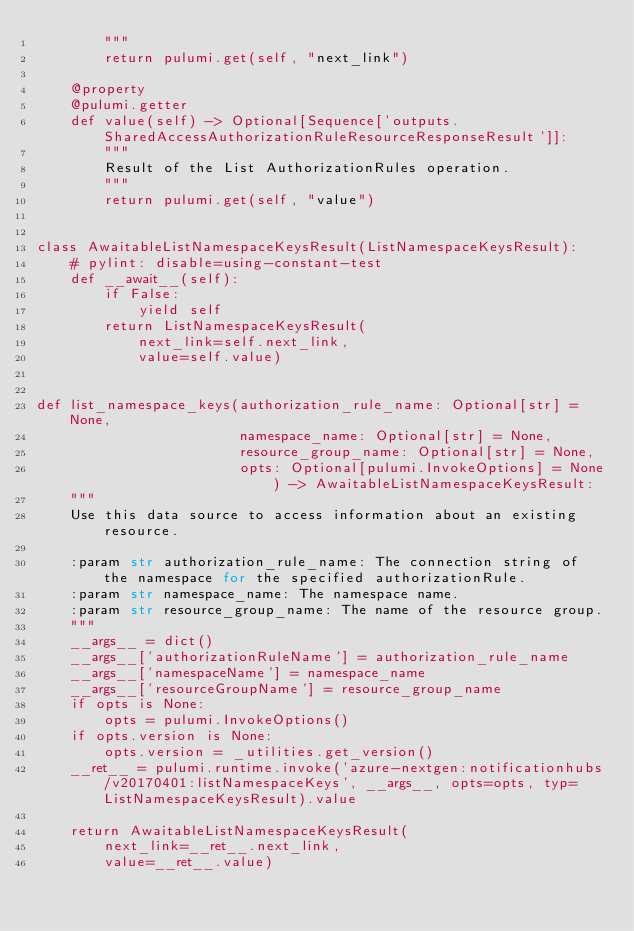<code> <loc_0><loc_0><loc_500><loc_500><_Python_>        """
        return pulumi.get(self, "next_link")

    @property
    @pulumi.getter
    def value(self) -> Optional[Sequence['outputs.SharedAccessAuthorizationRuleResourceResponseResult']]:
        """
        Result of the List AuthorizationRules operation.
        """
        return pulumi.get(self, "value")


class AwaitableListNamespaceKeysResult(ListNamespaceKeysResult):
    # pylint: disable=using-constant-test
    def __await__(self):
        if False:
            yield self
        return ListNamespaceKeysResult(
            next_link=self.next_link,
            value=self.value)


def list_namespace_keys(authorization_rule_name: Optional[str] = None,
                        namespace_name: Optional[str] = None,
                        resource_group_name: Optional[str] = None,
                        opts: Optional[pulumi.InvokeOptions] = None) -> AwaitableListNamespaceKeysResult:
    """
    Use this data source to access information about an existing resource.

    :param str authorization_rule_name: The connection string of the namespace for the specified authorizationRule.
    :param str namespace_name: The namespace name.
    :param str resource_group_name: The name of the resource group.
    """
    __args__ = dict()
    __args__['authorizationRuleName'] = authorization_rule_name
    __args__['namespaceName'] = namespace_name
    __args__['resourceGroupName'] = resource_group_name
    if opts is None:
        opts = pulumi.InvokeOptions()
    if opts.version is None:
        opts.version = _utilities.get_version()
    __ret__ = pulumi.runtime.invoke('azure-nextgen:notificationhubs/v20170401:listNamespaceKeys', __args__, opts=opts, typ=ListNamespaceKeysResult).value

    return AwaitableListNamespaceKeysResult(
        next_link=__ret__.next_link,
        value=__ret__.value)
</code> 